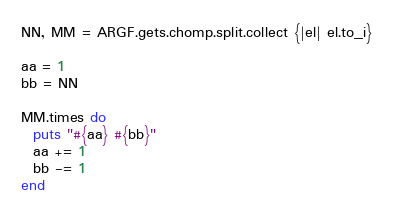Convert code to text. <code><loc_0><loc_0><loc_500><loc_500><_Ruby_>NN, MM = ARGF.gets.chomp.split.collect {|el| el.to_i}

aa = 1
bb = NN

MM.times do
  puts "#{aa} #{bb}"
  aa += 1
  bb -= 1
end

</code> 